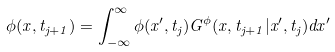<formula> <loc_0><loc_0><loc_500><loc_500>\phi ( x , t _ { j + 1 } ) = \int _ { - \infty } ^ { \infty } \phi ( x ^ { \prime } , t _ { j } ) G ^ { \phi } ( x , t _ { j + 1 } | x ^ { \prime } , t _ { j } ) d x ^ { \prime }</formula> 